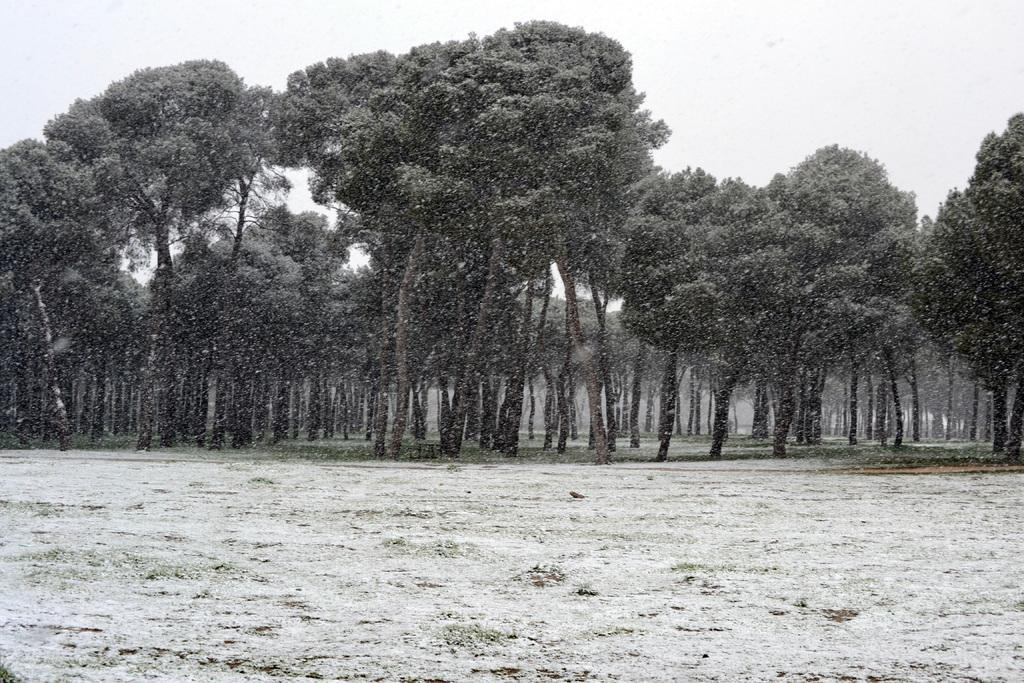What type of vegetation is present in the image? There are trees in the image. Can you describe the trees in more detail? The trees have branches and leaves. What is the condition of the ground in the image? There appears to be a muddy area in the image. What is visible in the background of the image? The sky is visible in the image. How many dolls can be seen sitting on the wheel in the image? There are no dolls or wheels present in the image. Can you spot any ladybugs crawling on the leaves of the trees in the image? There is no mention of ladybugs in the provided facts, so we cannot determine their presence in the image. 